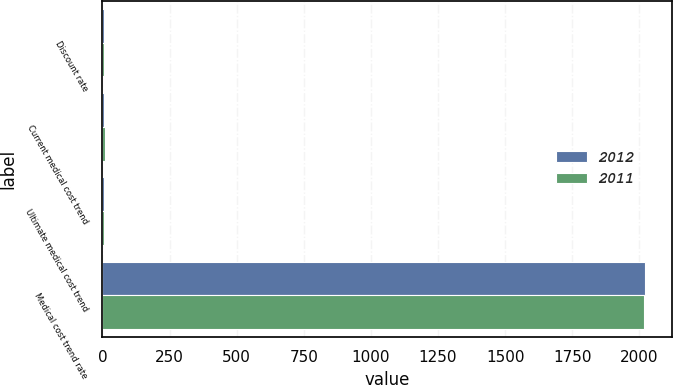<chart> <loc_0><loc_0><loc_500><loc_500><stacked_bar_chart><ecel><fcel>Discount rate<fcel>Current medical cost trend<fcel>Ultimate medical cost trend<fcel>Medical cost trend rate<nl><fcel>2012<fcel>4.6<fcel>7<fcel>4.75<fcel>2021<nl><fcel>2011<fcel>5.5<fcel>8<fcel>4.75<fcel>2016<nl></chart> 